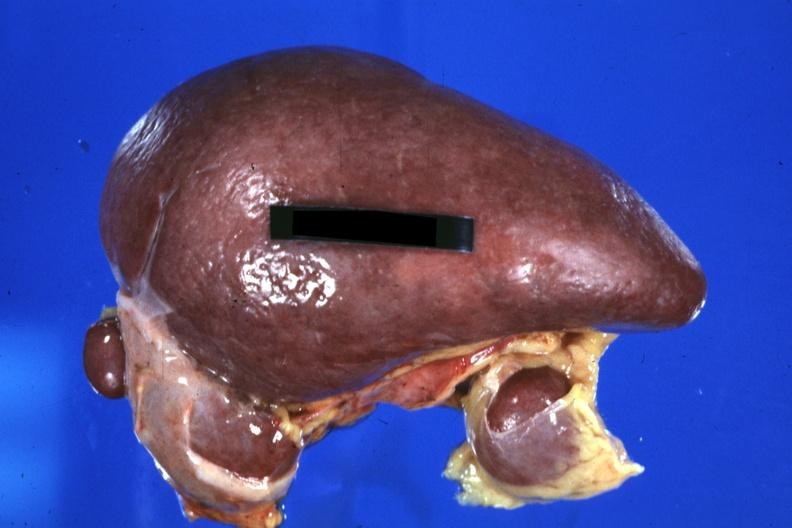where is this part in?
Answer the question using a single word or phrase. Spleen 